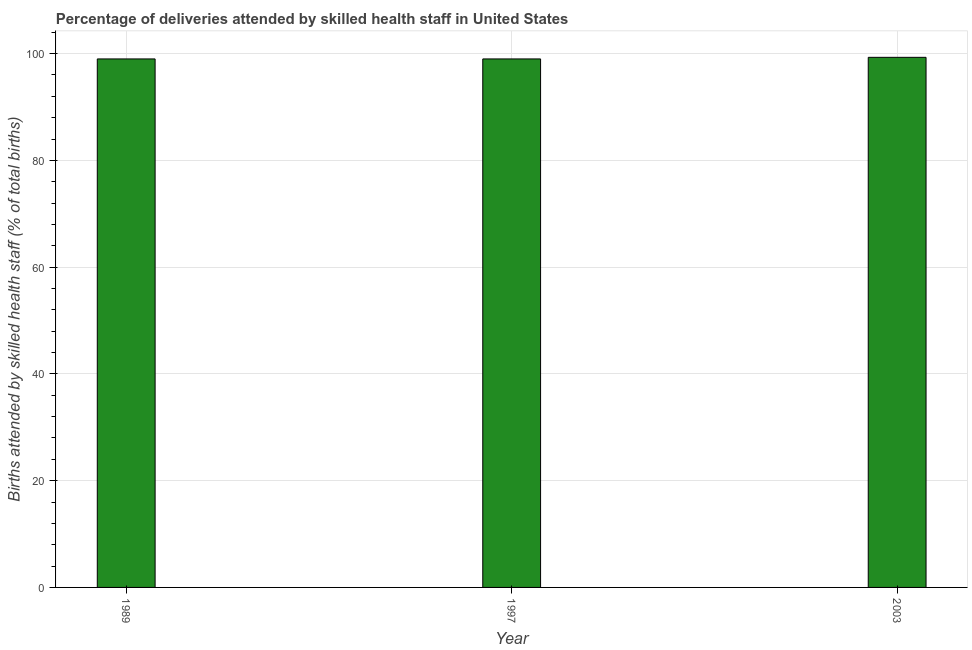Does the graph contain any zero values?
Offer a terse response. No. What is the title of the graph?
Your response must be concise. Percentage of deliveries attended by skilled health staff in United States. What is the label or title of the X-axis?
Keep it short and to the point. Year. What is the label or title of the Y-axis?
Offer a terse response. Births attended by skilled health staff (% of total births). What is the number of births attended by skilled health staff in 1997?
Offer a very short reply. 99. Across all years, what is the maximum number of births attended by skilled health staff?
Your response must be concise. 99.3. In which year was the number of births attended by skilled health staff minimum?
Your answer should be compact. 1989. What is the sum of the number of births attended by skilled health staff?
Your response must be concise. 297.3. What is the average number of births attended by skilled health staff per year?
Keep it short and to the point. 99.1. What is the difference between the highest and the second highest number of births attended by skilled health staff?
Offer a very short reply. 0.3. In how many years, is the number of births attended by skilled health staff greater than the average number of births attended by skilled health staff taken over all years?
Provide a short and direct response. 1. Are all the bars in the graph horizontal?
Make the answer very short. No. What is the difference between two consecutive major ticks on the Y-axis?
Your answer should be very brief. 20. What is the Births attended by skilled health staff (% of total births) in 2003?
Your answer should be very brief. 99.3. What is the difference between the Births attended by skilled health staff (% of total births) in 1989 and 1997?
Provide a succinct answer. 0. What is the ratio of the Births attended by skilled health staff (% of total births) in 1989 to that in 1997?
Your response must be concise. 1. What is the ratio of the Births attended by skilled health staff (% of total births) in 1997 to that in 2003?
Give a very brief answer. 1. 